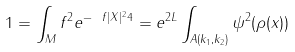Convert formula to latex. <formula><loc_0><loc_0><loc_500><loc_500>1 = \int _ { M } f ^ { 2 } e ^ { - \ f { | X | ^ { 2 } } 4 } = e ^ { 2 L } \int _ { A ( k _ { 1 } , k _ { 2 } ) } \psi ^ { 2 } ( \rho ( x ) )</formula> 